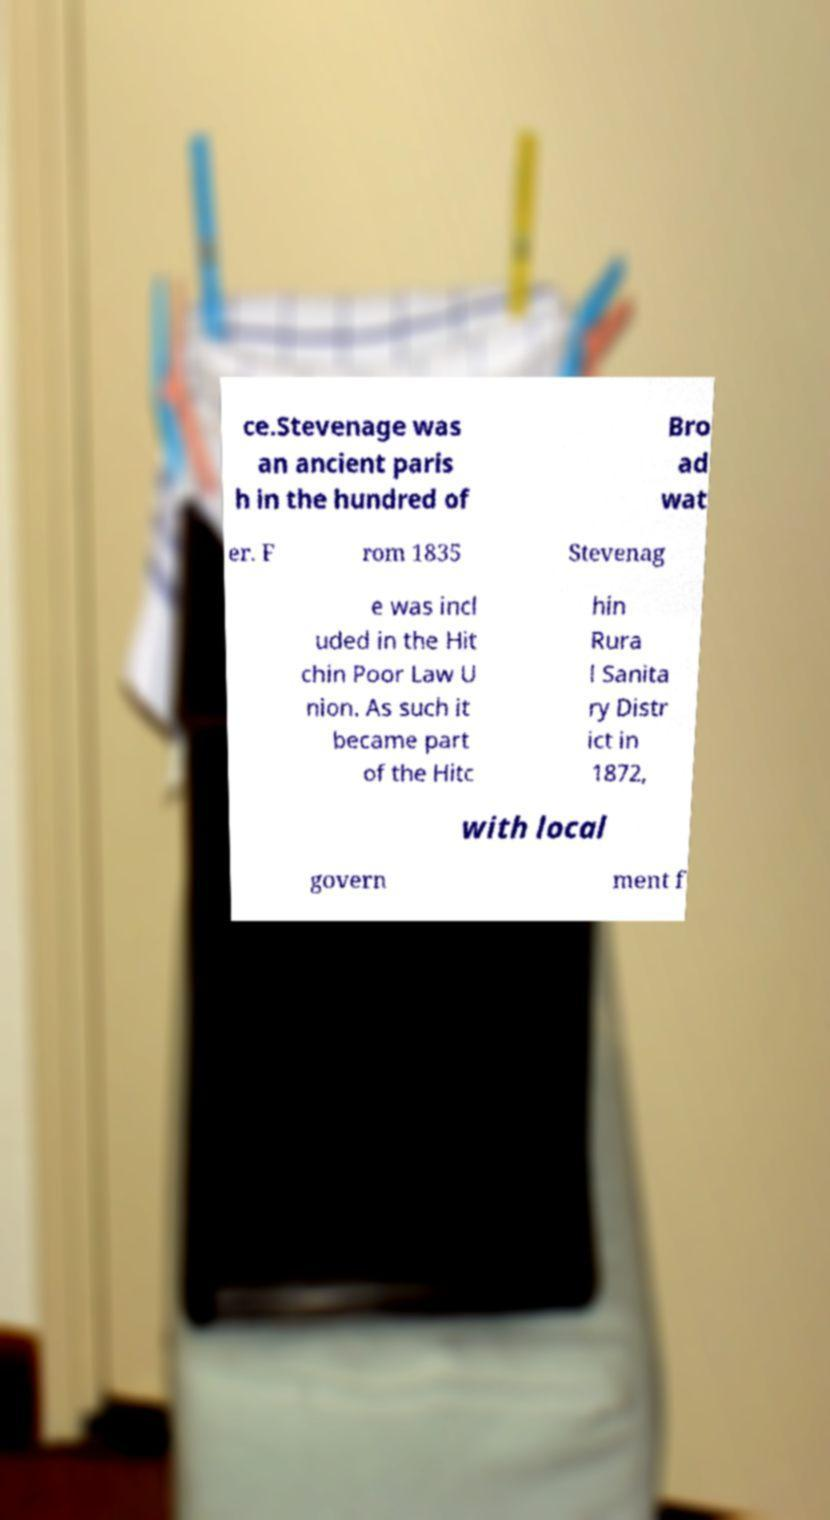Could you extract and type out the text from this image? ce.Stevenage was an ancient paris h in the hundred of Bro ad wat er. F rom 1835 Stevenag e was incl uded in the Hit chin Poor Law U nion. As such it became part of the Hitc hin Rura l Sanita ry Distr ict in 1872, with local govern ment f 